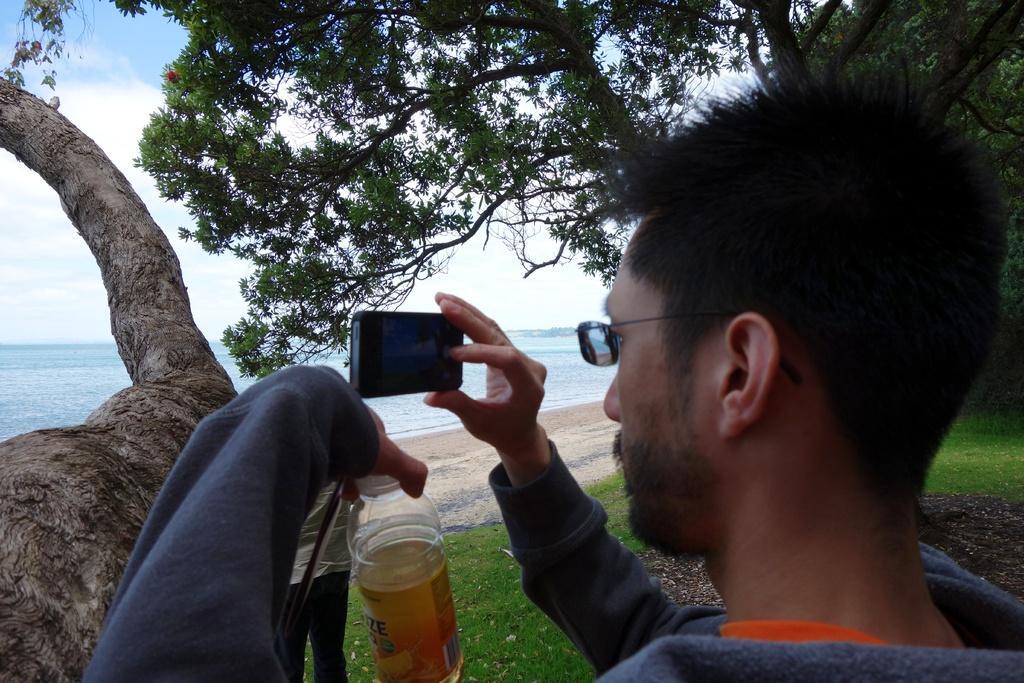In one or two sentences, can you explain what this image depicts? In this image there is a man standing. He is holding a bottle and a camera in his hand. In front of him there is another person standing. In the background there is the water. On the either sides of the image there are trees. There is grass on the ground. At the top there is the sky. 